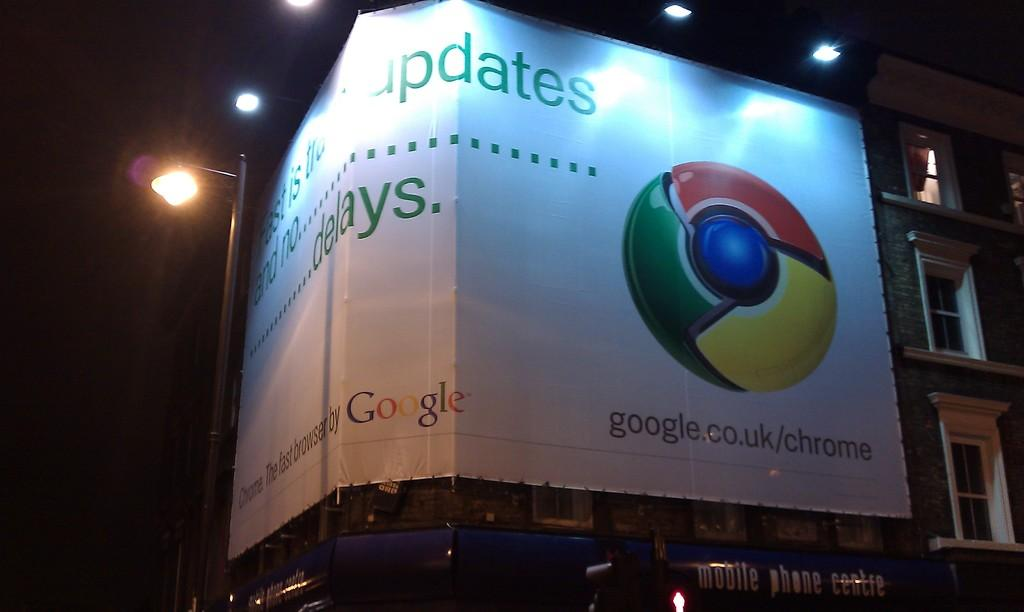Provide a one-sentence caption for the provided image. A large Google sign on a building says Updates and delays. 